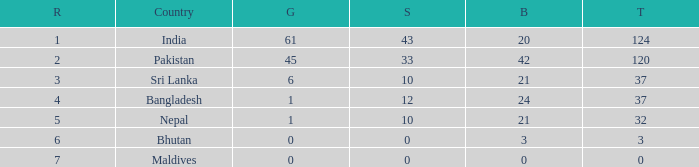Which Gold has a Rank smaller than 5, and a Bronze of 20? 61.0. 